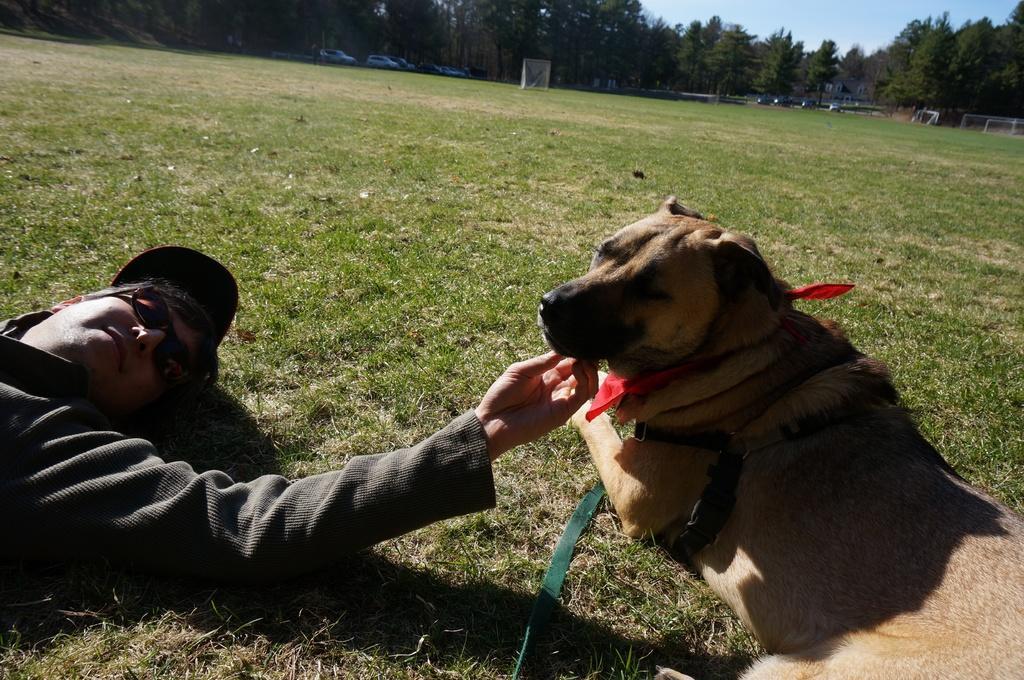How would you summarize this image in a sentence or two? A man is lying on the grass beside him there is a dog. In the background there are vehicles,trees and sky. 